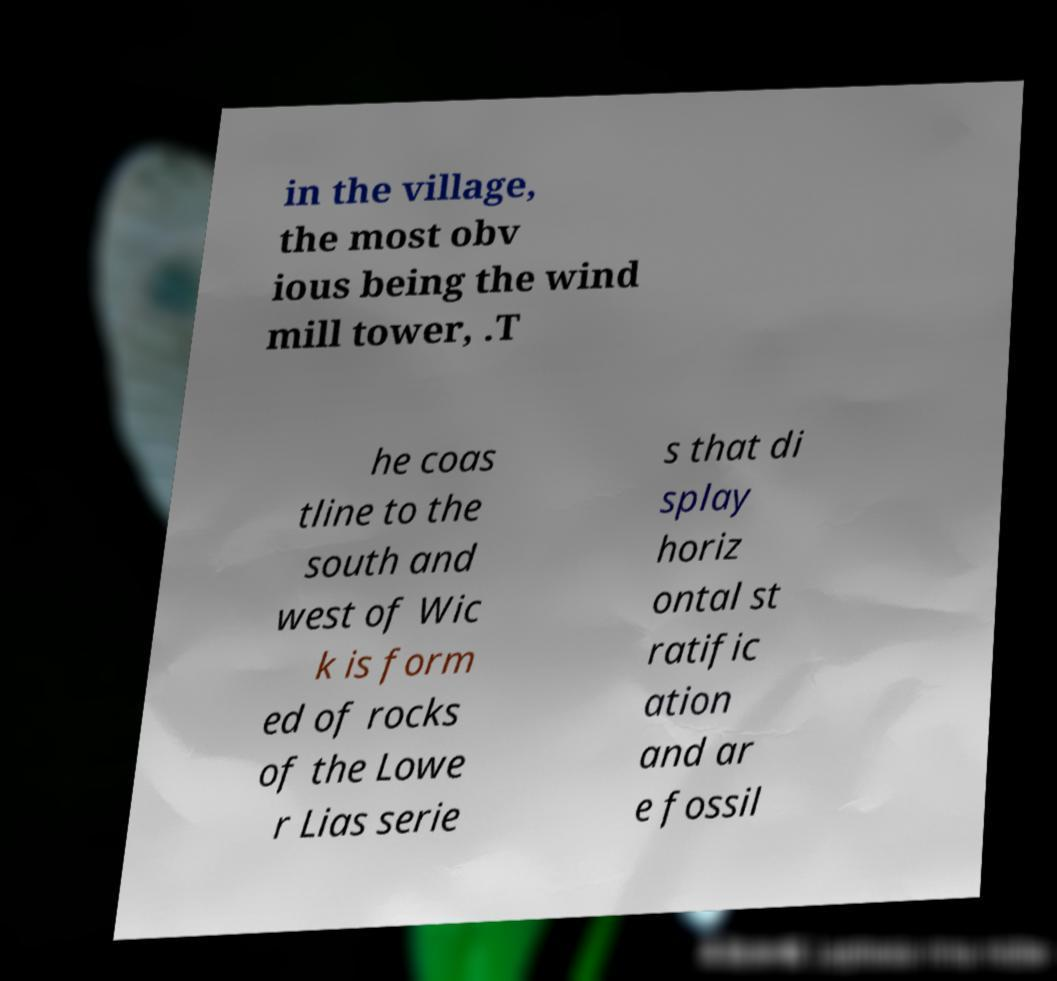For documentation purposes, I need the text within this image transcribed. Could you provide that? in the village, the most obv ious being the wind mill tower, .T he coas tline to the south and west of Wic k is form ed of rocks of the Lowe r Lias serie s that di splay horiz ontal st ratific ation and ar e fossil 